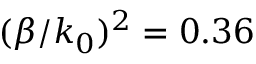Convert formula to latex. <formula><loc_0><loc_0><loc_500><loc_500>( \beta / k _ { 0 } ) ^ { 2 } = 0 . 3 6</formula> 